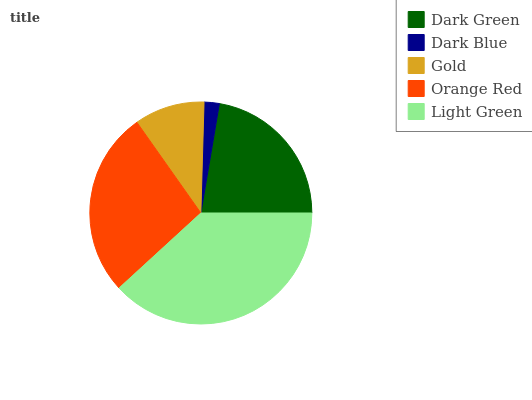Is Dark Blue the minimum?
Answer yes or no. Yes. Is Light Green the maximum?
Answer yes or no. Yes. Is Gold the minimum?
Answer yes or no. No. Is Gold the maximum?
Answer yes or no. No. Is Gold greater than Dark Blue?
Answer yes or no. Yes. Is Dark Blue less than Gold?
Answer yes or no. Yes. Is Dark Blue greater than Gold?
Answer yes or no. No. Is Gold less than Dark Blue?
Answer yes or no. No. Is Dark Green the high median?
Answer yes or no. Yes. Is Dark Green the low median?
Answer yes or no. Yes. Is Gold the high median?
Answer yes or no. No. Is Dark Blue the low median?
Answer yes or no. No. 